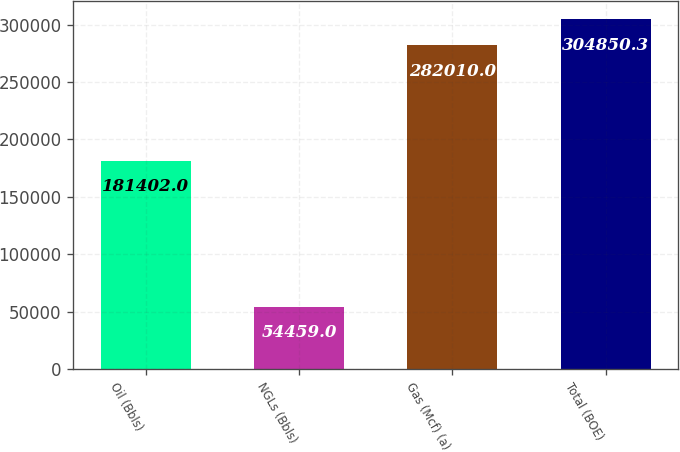Convert chart. <chart><loc_0><loc_0><loc_500><loc_500><bar_chart><fcel>Oil (Bbls)<fcel>NGLs (Bbls)<fcel>Gas (Mcf) (a)<fcel>Total (BOE)<nl><fcel>181402<fcel>54459<fcel>282010<fcel>304850<nl></chart> 